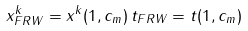Convert formula to latex. <formula><loc_0><loc_0><loc_500><loc_500>x ^ { k } _ { F R W } = x ^ { k } ( 1 , c _ { m } ) \, t _ { F R W } = t ( 1 , c _ { m } )</formula> 